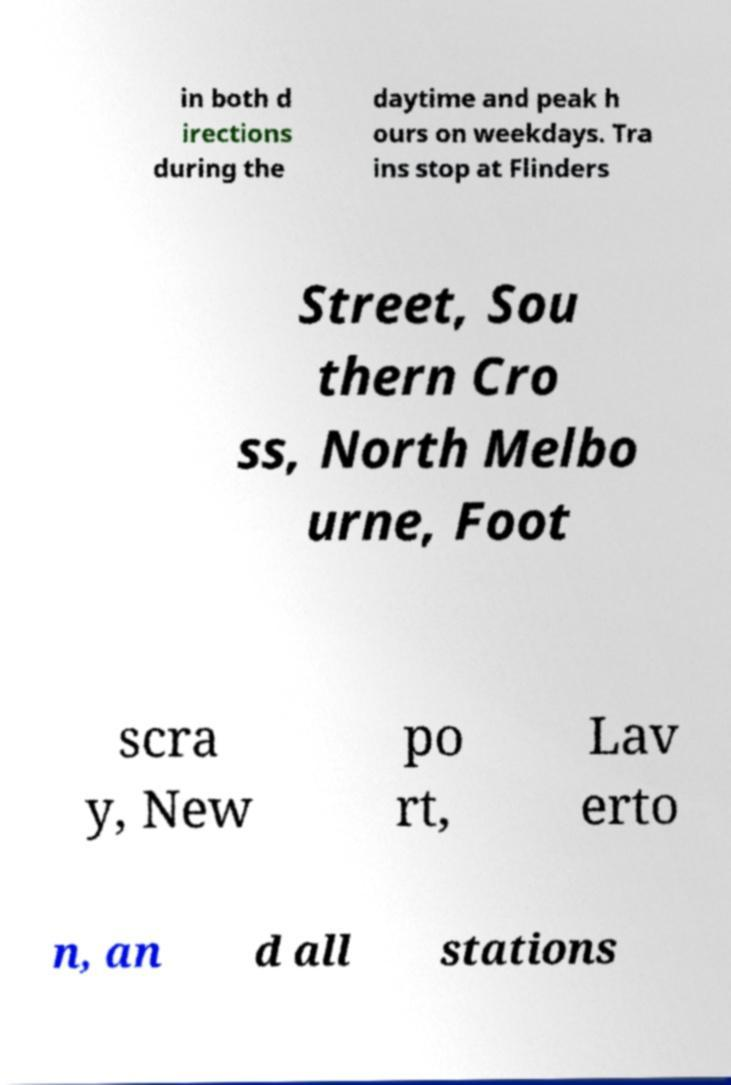Please read and relay the text visible in this image. What does it say? in both d irections during the daytime and peak h ours on weekdays. Tra ins stop at Flinders Street, Sou thern Cro ss, North Melbo urne, Foot scra y, New po rt, Lav erto n, an d all stations 